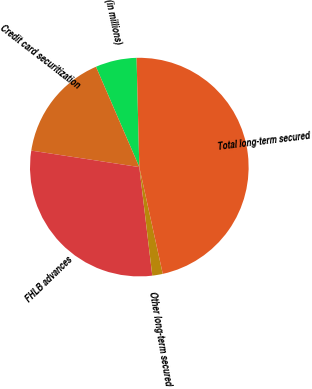Convert chart. <chart><loc_0><loc_0><loc_500><loc_500><pie_chart><fcel>(in millions)<fcel>Credit card securitization<fcel>FHLB advances<fcel>Other long-term secured<fcel>Total long-term secured<nl><fcel>6.09%<fcel>16.1%<fcel>29.31%<fcel>1.55%<fcel>46.96%<nl></chart> 